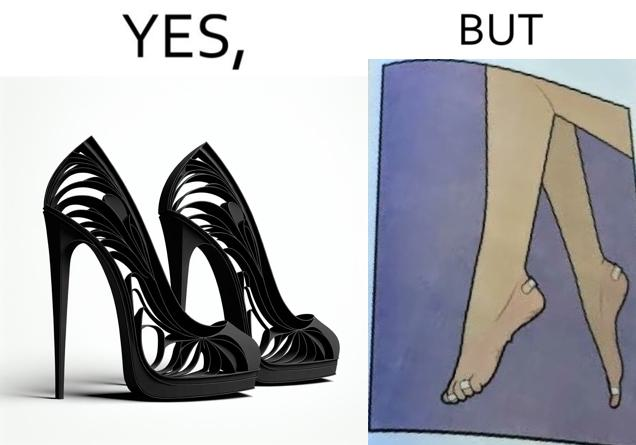What do you see in each half of this image? In the left part of the image: a pair of high heeled shoes In the right part of the image: A pair of feet, blistered and red, with bandages 